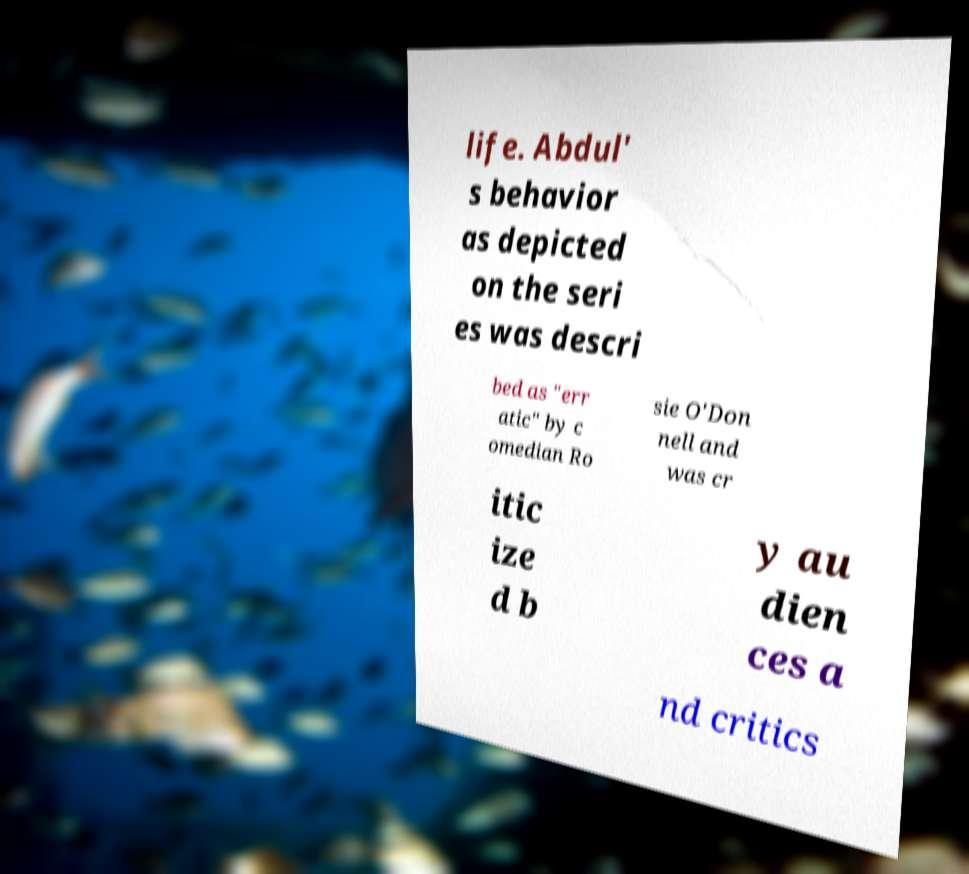Can you read and provide the text displayed in the image?This photo seems to have some interesting text. Can you extract and type it out for me? life. Abdul' s behavior as depicted on the seri es was descri bed as "err atic" by c omedian Ro sie O'Don nell and was cr itic ize d b y au dien ces a nd critics 